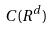Convert formula to latex. <formula><loc_0><loc_0><loc_500><loc_500>C ( R ^ { d } )</formula> 